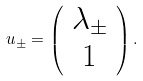<formula> <loc_0><loc_0><loc_500><loc_500>u _ { \pm } = \left ( \begin{array} { c } \lambda _ { \pm } \\ 1 \end{array} \right ) .</formula> 